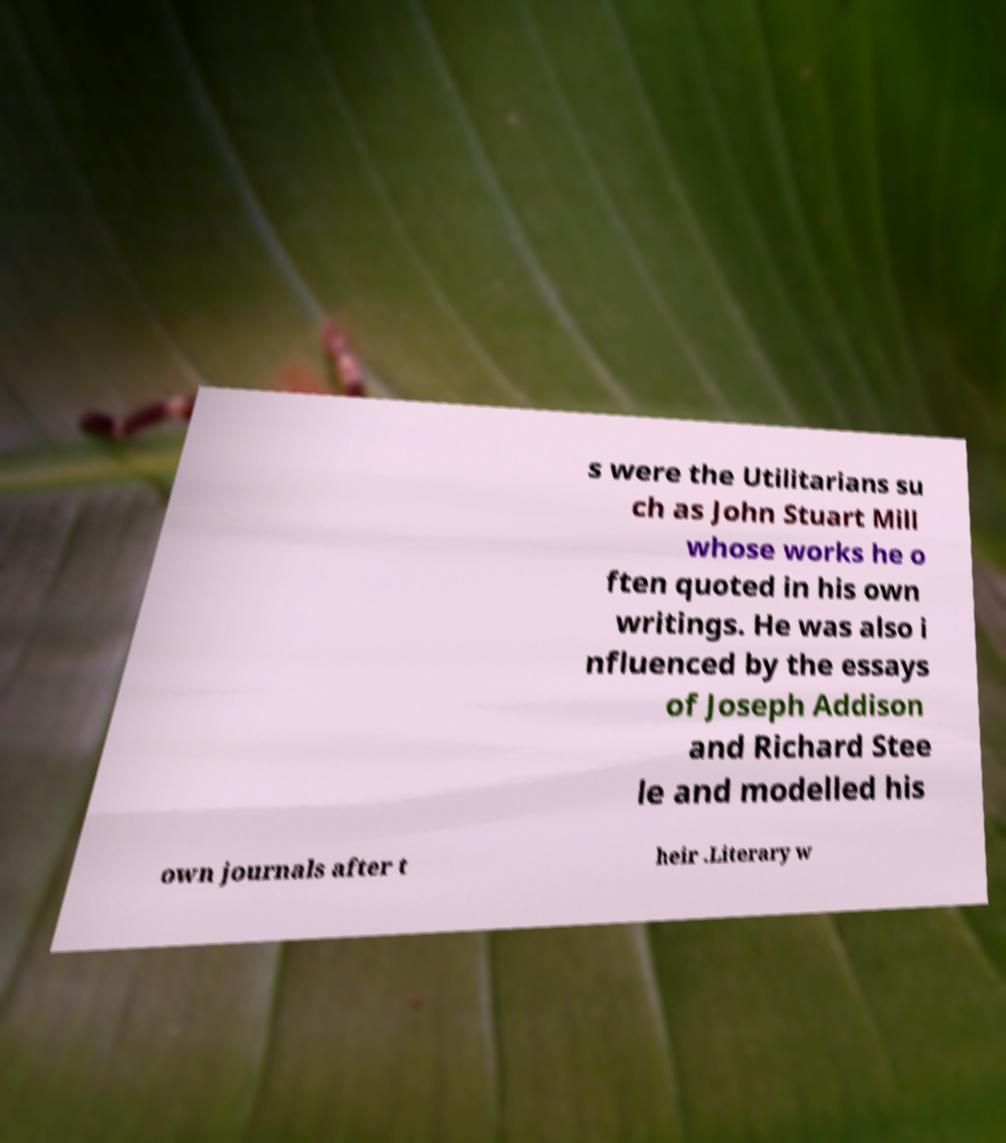For documentation purposes, I need the text within this image transcribed. Could you provide that? s were the Utilitarians su ch as John Stuart Mill whose works he o ften quoted in his own writings. He was also i nfluenced by the essays of Joseph Addison and Richard Stee le and modelled his own journals after t heir .Literary w 